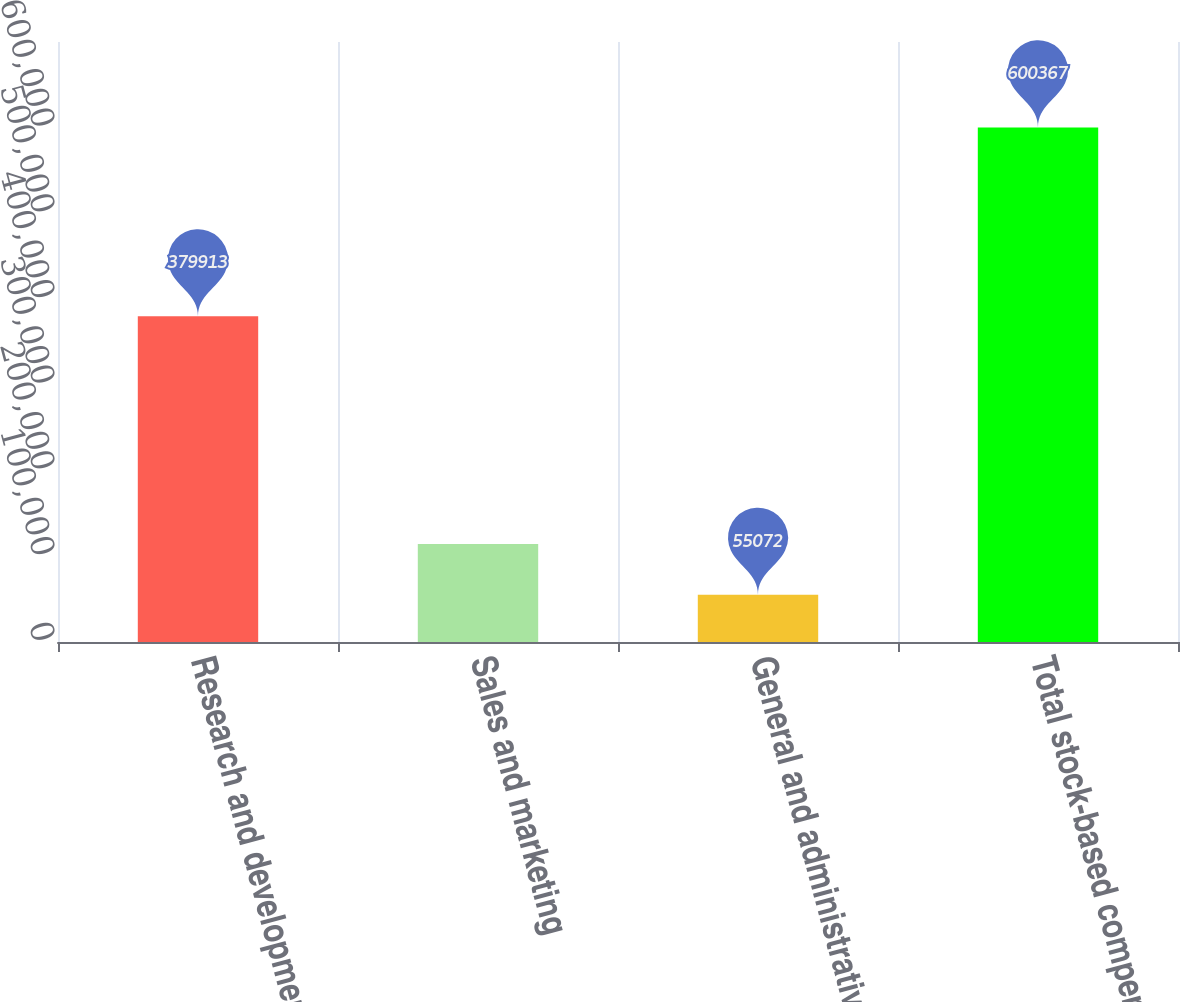Convert chart. <chart><loc_0><loc_0><loc_500><loc_500><bar_chart><fcel>Research and development<fcel>Sales and marketing<fcel>General and administrative<fcel>Total stock-based compensation<nl><fcel>379913<fcel>114440<fcel>55072<fcel>600367<nl></chart> 